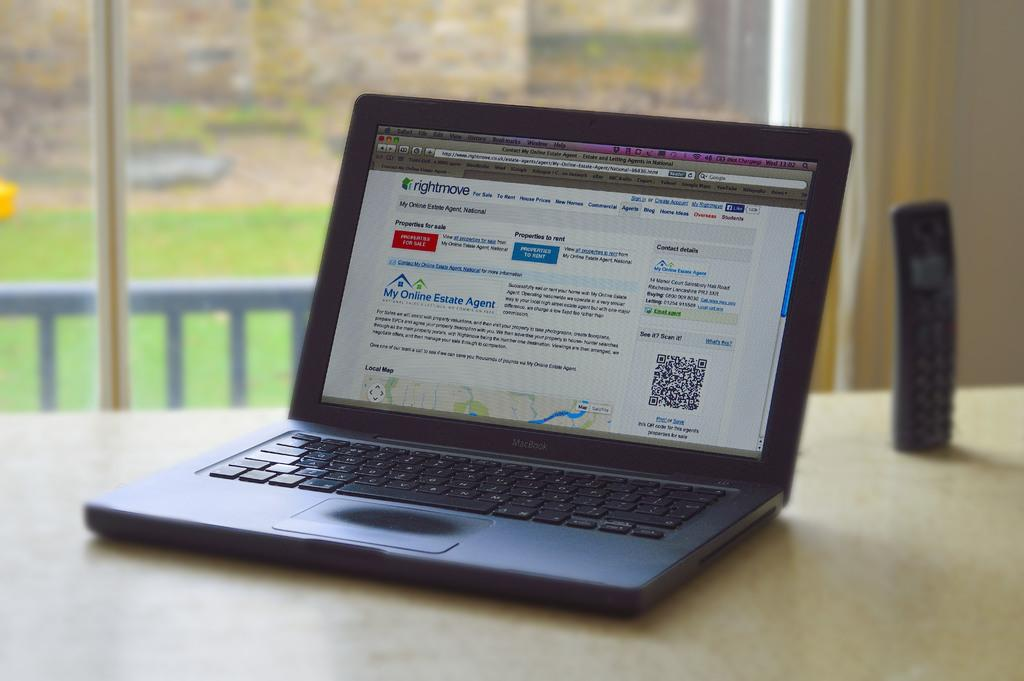<image>
Describe the image concisely. a black macbook laptop with an open page that says rightmove on the top left of it 